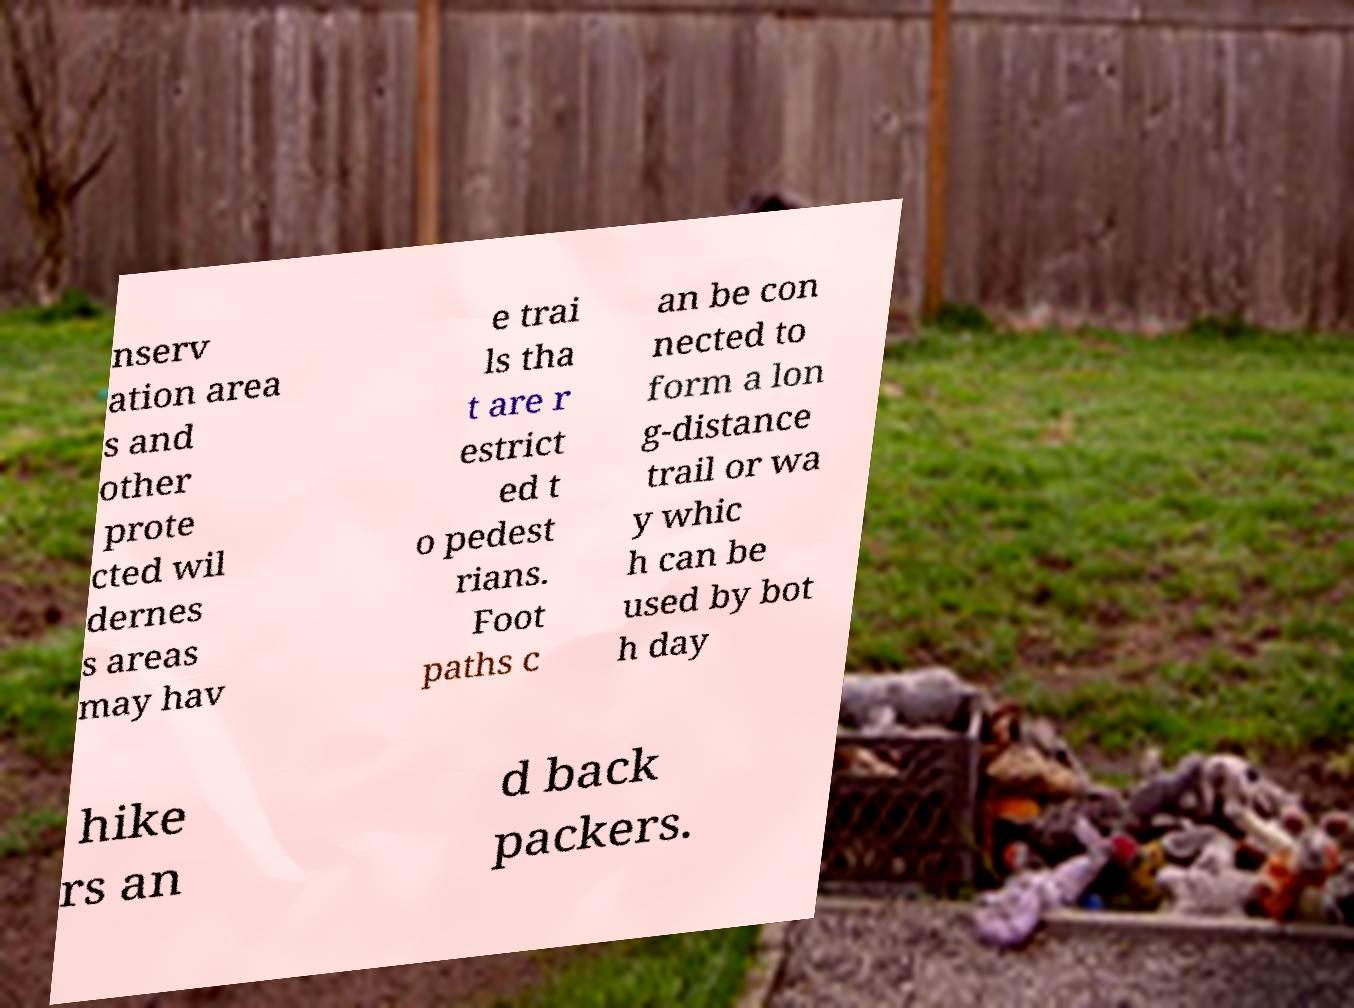What messages or text are displayed in this image? I need them in a readable, typed format. nserv ation area s and other prote cted wil dernes s areas may hav e trai ls tha t are r estrict ed t o pedest rians. Foot paths c an be con nected to form a lon g-distance trail or wa y whic h can be used by bot h day hike rs an d back packers. 